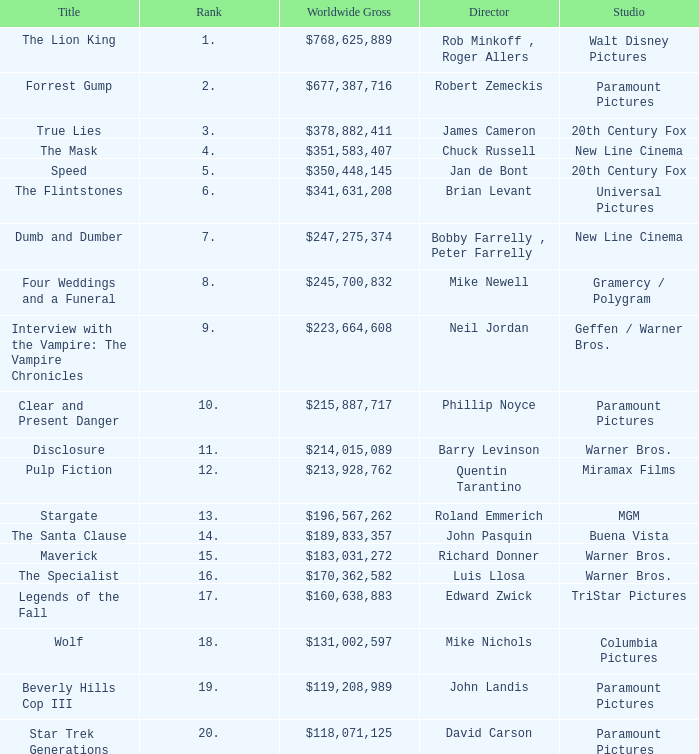What is the Title of the Film with a Rank greater than 11 and Worldwide Gross of $131,002,597? Wolf. 